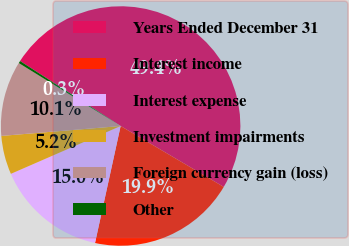Convert chart to OTSL. <chart><loc_0><loc_0><loc_500><loc_500><pie_chart><fcel>Years Ended December 31<fcel>Interest income<fcel>Interest expense<fcel>Investment impairments<fcel>Foreign currency gain (loss)<fcel>Other<nl><fcel>49.36%<fcel>19.94%<fcel>15.03%<fcel>5.22%<fcel>10.13%<fcel>0.32%<nl></chart> 